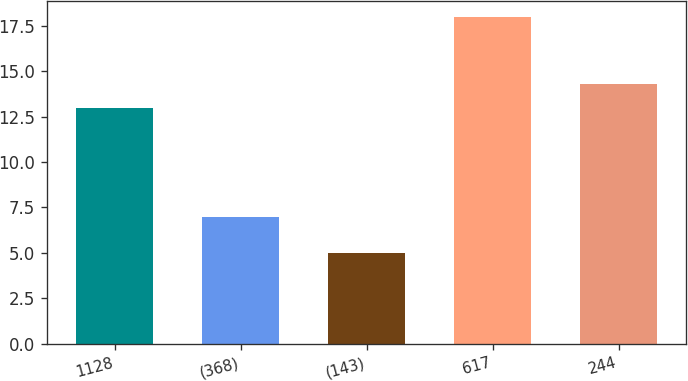Convert chart to OTSL. <chart><loc_0><loc_0><loc_500><loc_500><bar_chart><fcel>1128<fcel>(368)<fcel>(143)<fcel>617<fcel>244<nl><fcel>13<fcel>7<fcel>5<fcel>18<fcel>14.3<nl></chart> 